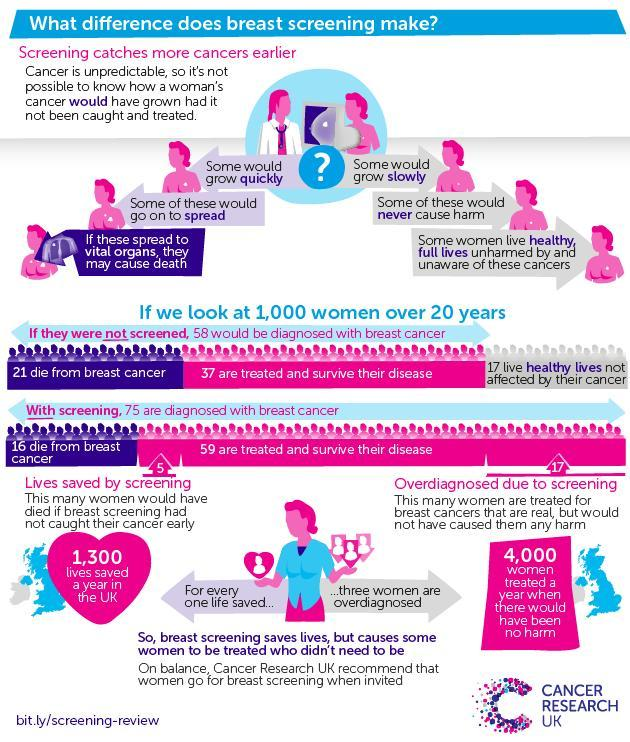If there was no screening, how many women would have died due to Breast cancer?
Answer the question with a short phrase. 21 What is the biggest disadvantage of breast cancer screening? causes some women to be treated who didn't need to be How many women have recovered from breast cancer after diagnosing it through screening? 59 How many women were saved from cancer through screening? 5 How many women were given treatment for breast cancer whom their life was not at risk at all? 4,000 How many women died because of breast cancer after screening? 16 How many women got recovered from breast cancer out of 58? 37 